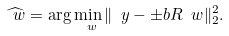Convert formula to latex. <formula><loc_0><loc_0><loc_500><loc_500>\widehat { \ w } = \arg \min _ { \ w } \| \ y - \pm b { R } \ w \| _ { 2 } ^ { 2 } .</formula> 